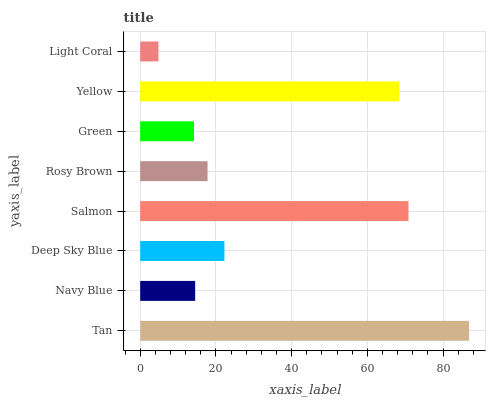Is Light Coral the minimum?
Answer yes or no. Yes. Is Tan the maximum?
Answer yes or no. Yes. Is Navy Blue the minimum?
Answer yes or no. No. Is Navy Blue the maximum?
Answer yes or no. No. Is Tan greater than Navy Blue?
Answer yes or no. Yes. Is Navy Blue less than Tan?
Answer yes or no. Yes. Is Navy Blue greater than Tan?
Answer yes or no. No. Is Tan less than Navy Blue?
Answer yes or no. No. Is Deep Sky Blue the high median?
Answer yes or no. Yes. Is Rosy Brown the low median?
Answer yes or no. Yes. Is Rosy Brown the high median?
Answer yes or no. No. Is Yellow the low median?
Answer yes or no. No. 